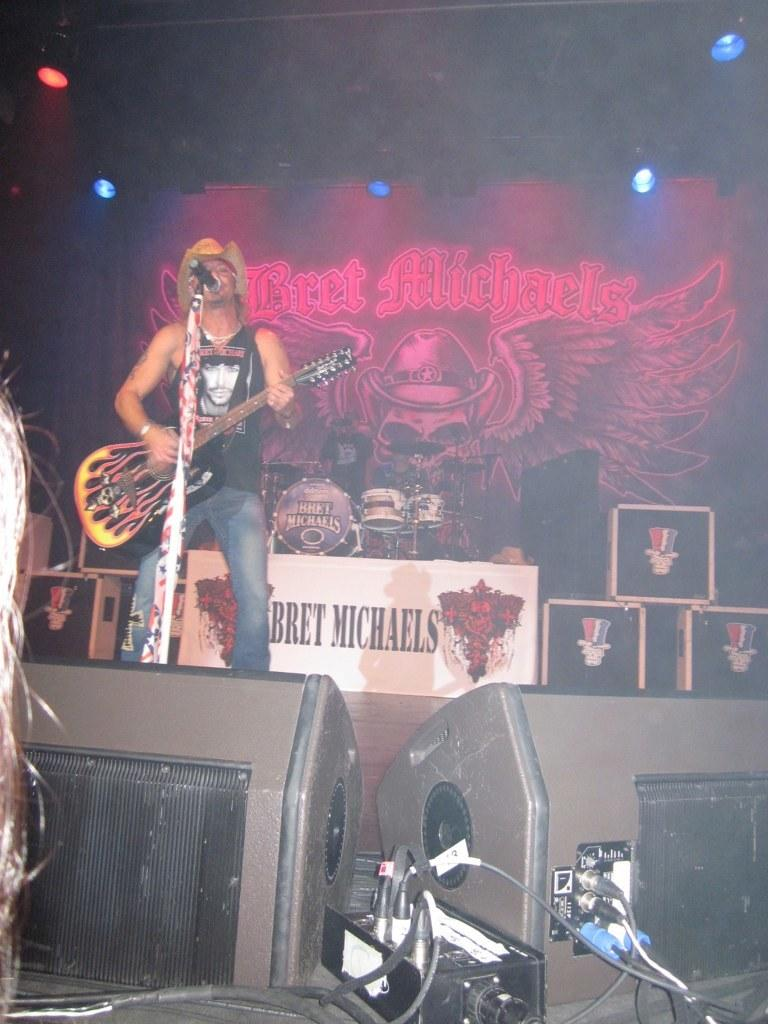What is the person on the stage doing? The person is playing the guitar and singing into a microphone. Where is the person positioned on the stage? The person is on the left side of the stage. What instrument is the person holding? The person is holding a guitar. Can you see any smoke coming from the person's house in the image? There is no house or smoke present in the image; it features a person on a stage. 